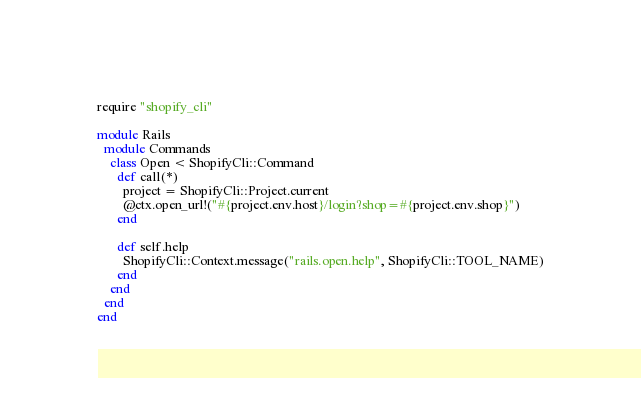Convert code to text. <code><loc_0><loc_0><loc_500><loc_500><_Ruby_>require "shopify_cli"

module Rails
  module Commands
    class Open < ShopifyCli::Command
      def call(*)
        project = ShopifyCli::Project.current
        @ctx.open_url!("#{project.env.host}/login?shop=#{project.env.shop}")
      end

      def self.help
        ShopifyCli::Context.message("rails.open.help", ShopifyCli::TOOL_NAME)
      end
    end
  end
end
</code> 